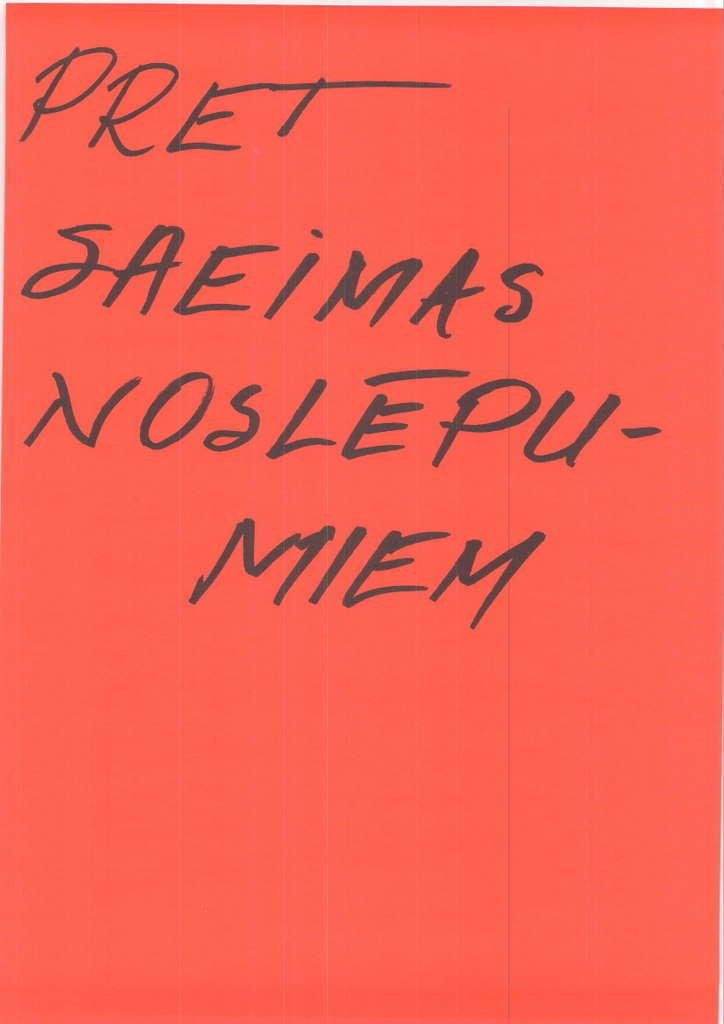<image>
Describe the image concisely. A red note that says PRet Saeimas Noslepu-Miem. 